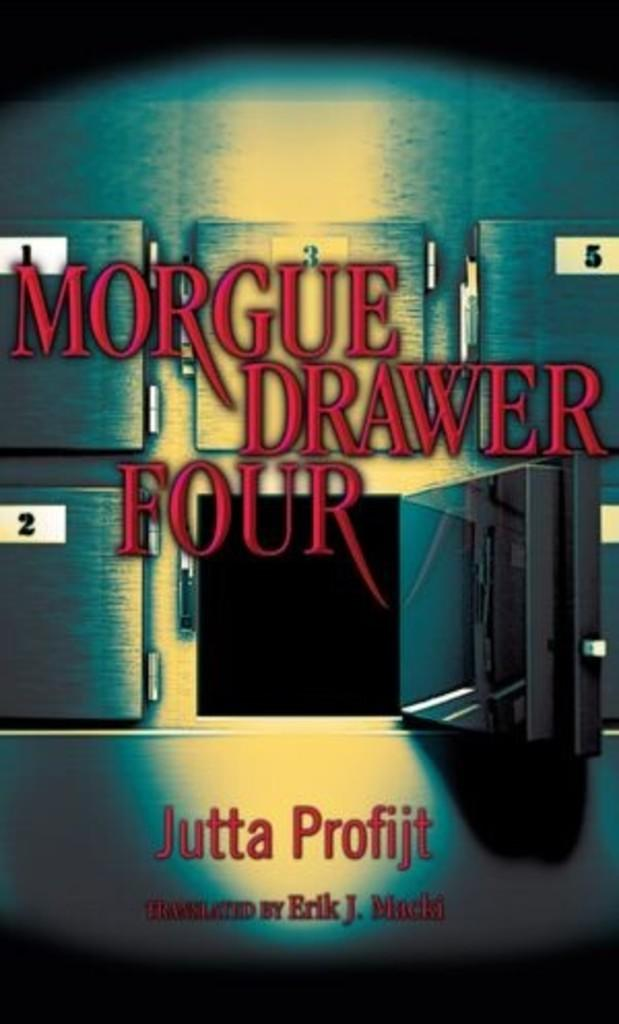<image>
Write a terse but informative summary of the picture. A book called Morgue Drawer Four by Jutta Profijt. 